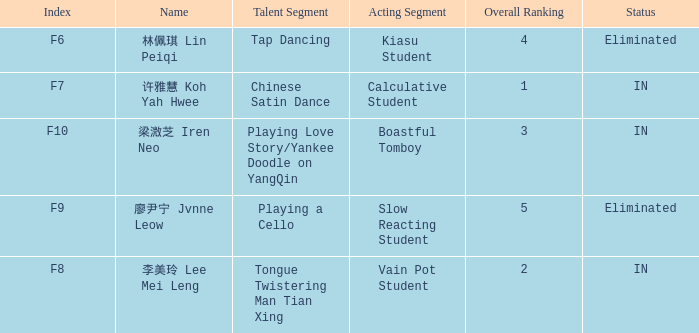For all events with index f10, what is the sum of the overall rankings? 3.0. 